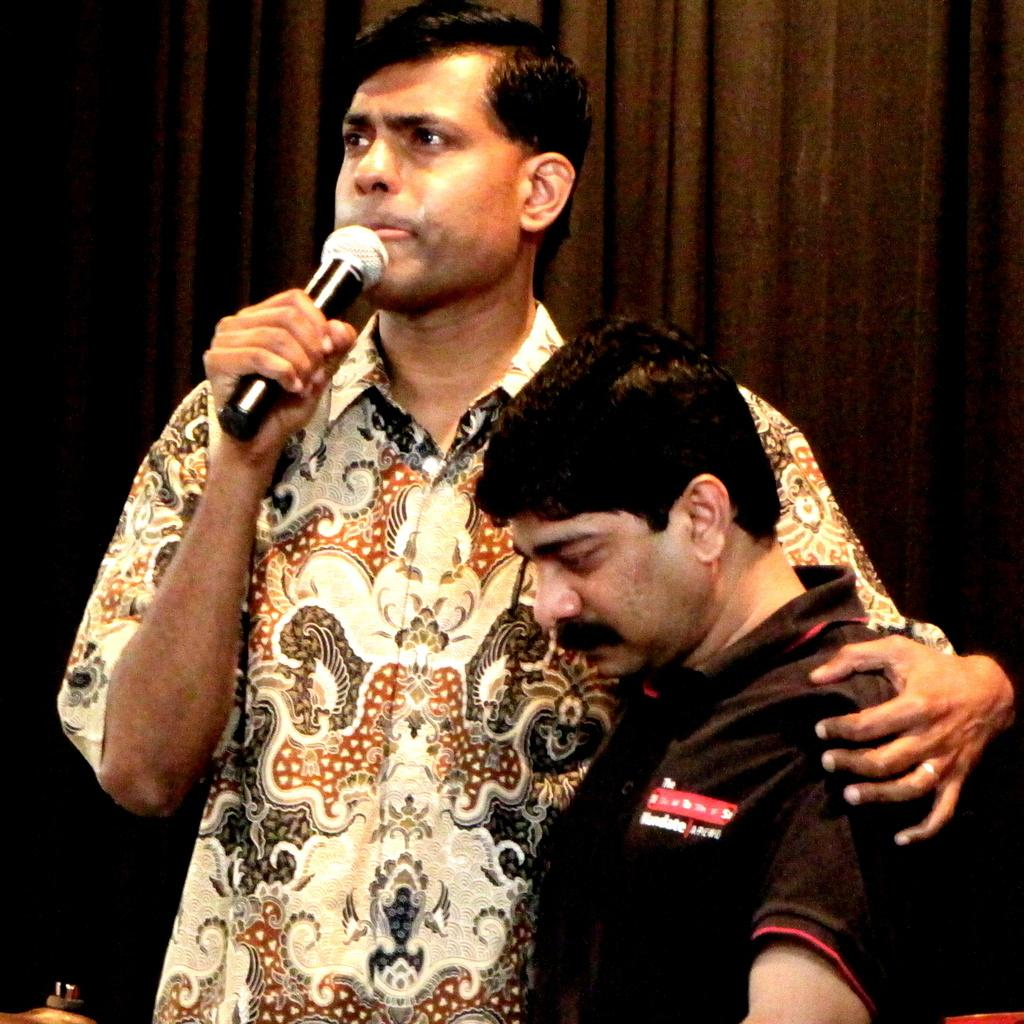What is the man in the image wearing? There is a man wearing a shirt in the image. What is the man holding in his hands? The man is holding a mic in his hands. Can you describe the other man in the image? There is another man wearing a black t-shirt in the image, and he is standing behind the first man. What can be seen in the background of the image? There are curtains visible in the background of the image. How does the man in the image react to the shock of water in the image? There is no water or shock present in the image; it features two men and a mic. 